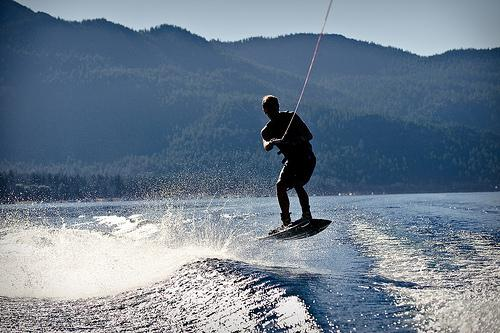Question: why is the man in the water?
Choices:
A. Exercise.
B. For fun.
C. For a picture.
D. For leisure.
Answer with the letter. Answer: D Question: when was the photo taken?
Choices:
A. In the summer.
B. In the fall.
C. During the day.
D. In the winter.
Answer with the letter. Answer: C Question: who is jet skiing?
Choices:
A. A woman.
B. A man.
C. A boy.
D. A girl.
Answer with the letter. Answer: B Question: where was the photo taken?
Choices:
A. The diner.
B. The ocean.
C. In the river.
D. The beach.
Answer with the letter. Answer: B Question: what is the man doing?
Choices:
A. Jet skiing.
B. Wake boarding.
C. Skiing.
D. Sledding.
Answer with the letter. Answer: A 